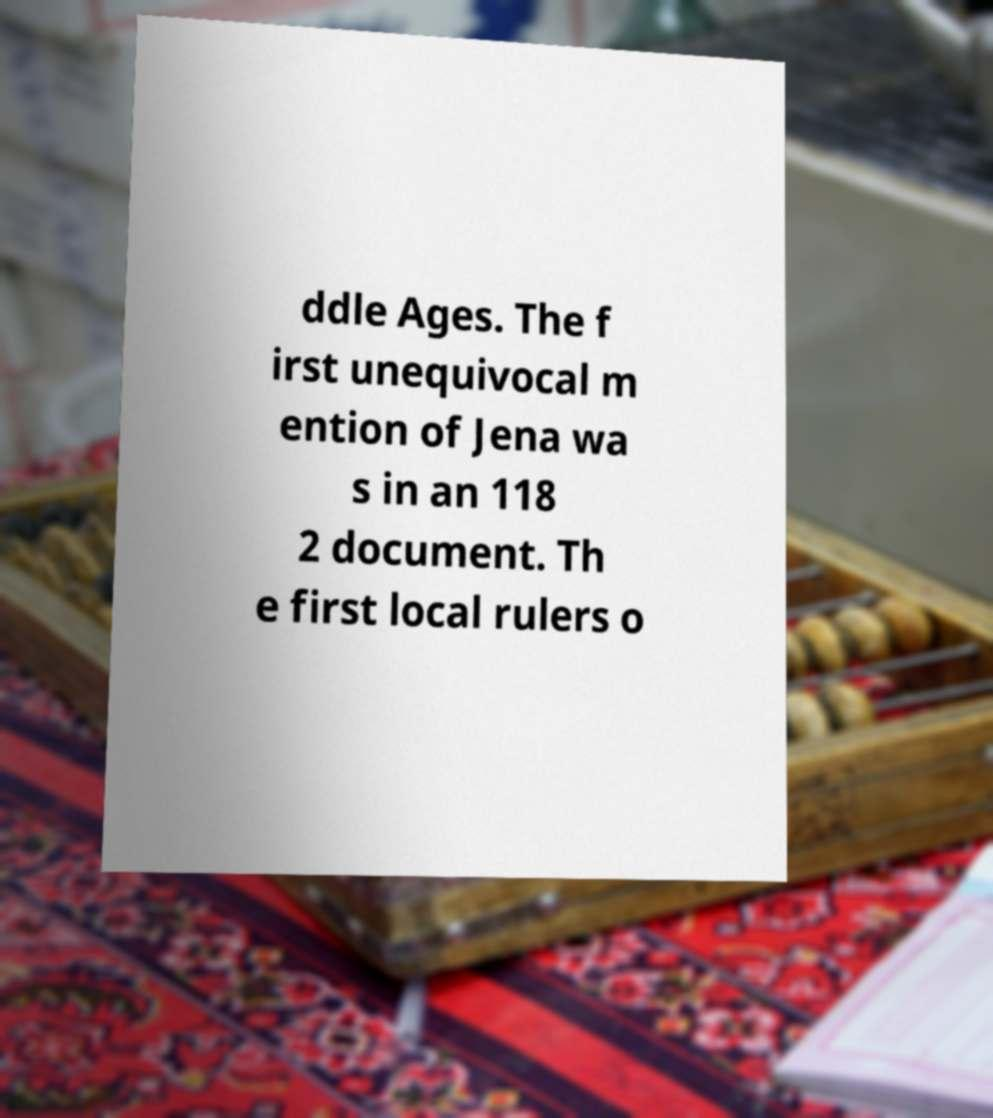Please read and relay the text visible in this image. What does it say? ddle Ages. The f irst unequivocal m ention of Jena wa s in an 118 2 document. Th e first local rulers o 